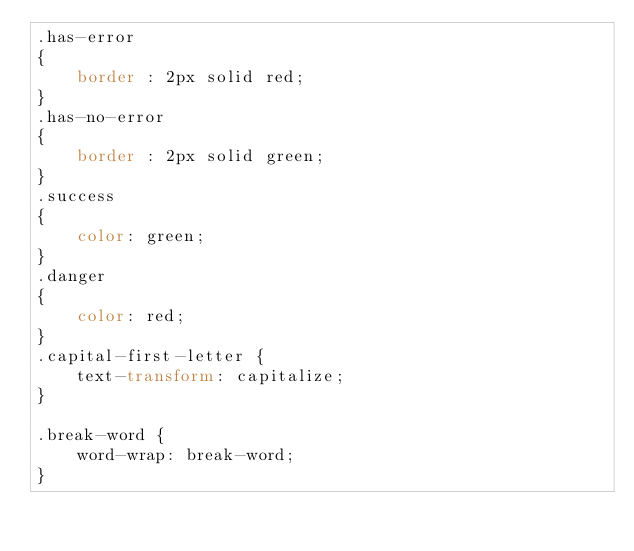<code> <loc_0><loc_0><loc_500><loc_500><_CSS_>.has-error
{
    border : 2px solid red;
}
.has-no-error
{
    border : 2px solid green;
}
.success
{
    color: green;
}
.danger
{
    color: red;
}
.capital-first-letter {
    text-transform: capitalize;
}

.break-word {
    word-wrap: break-word;
}</code> 